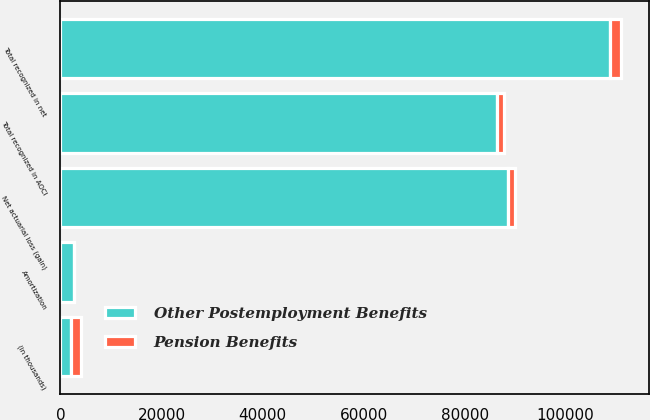<chart> <loc_0><loc_0><loc_500><loc_500><stacked_bar_chart><ecel><fcel>(in thousands)<fcel>Net actuarial loss (gain)<fcel>Amortization<fcel>Total recognized in AOCI<fcel>Total recognized in net<nl><fcel>Other Postemployment Benefits<fcel>2014<fcel>88607<fcel>2649<fcel>86315<fcel>108722<nl><fcel>Pension Benefits<fcel>2014<fcel>1445<fcel>1<fcel>1444<fcel>2224<nl></chart> 